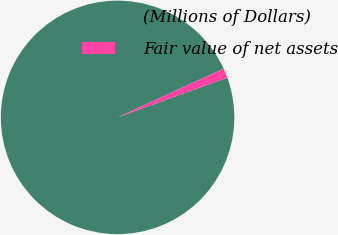Convert chart. <chart><loc_0><loc_0><loc_500><loc_500><pie_chart><fcel>(Millions of Dollars)<fcel>Fair value of net assets<nl><fcel>98.67%<fcel>1.33%<nl></chart> 